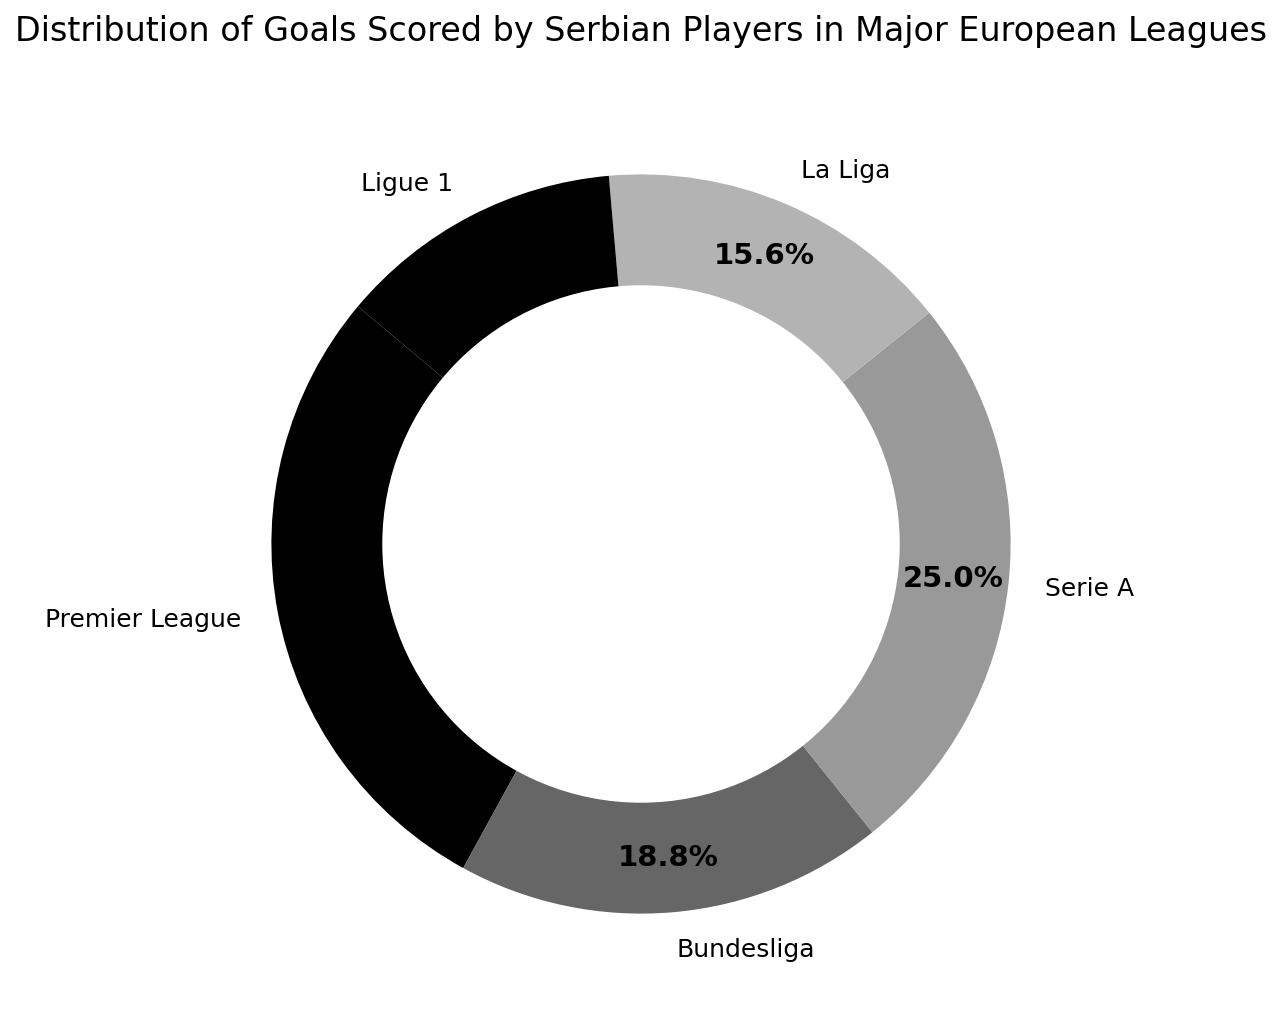Which league has the highest percentage of goals scored? The ring chart shows the distribution of goals scored by Serbian players in different leagues, represented in percentages. We look for the league with the largest segment in the chart.
Answer: Premier League What is the combined percentage of goals scored in the Bundesliga and La Liga? We find the segments for Bundesliga and La Liga and add their percentages. Bundesliga has 30 goals and La Liga has 25 goals, out of a total of 160 goals. Calculating: (30+25)/160 * 100 = 34.4%.
Answer: 34.4% How does the number of goals scored in Serie A compare to Ligue 1? We look at the segments representing Serie A and Ligue 1. Serie A has 40 goals and Ligue 1 has 20 goals. Serie A's segment is twice as large as Ligue 1's.
Answer: Serie A has twice as many goals as Ligue 1 Which league represents the smallest segment in the chart? The smallest segment in the ring chart represents the league with the least goals. By visual inspection, Ligue 1 has the smallest segment.
Answer: Ligue 1 What is the difference in the percentage of goals between the Premier League and La Liga? We find the percentages for Premier League and La Liga. Premier League’s percentage is ${45/160 * 100}$ and La Liga’s is ${25/160 * 100}$. The difference is ${(45/160 * 100) - (25/160 * 100)}$ = 12.5%.
Answer: 12.5% If goals in Ligue 1 doubled, what would be the new total number of goals and its percentage? Initially, Ligue 1 has 20 goals. Doubling it gives 40 goals. The new total number of goals will be 180 (160 original goals + 20 additional). The new percentage for Ligue 1 will be ${(40/180) * 100} = 22.2%$.
Answer: 22.2% What is the average number of goals scored per league? To find the average, sum the goals (45+30+40+25+20=160) and divide by the number of leagues (5). So, the average is ${160/5}$ = 32.
Answer: 32 Which two leagues have the most similar number of goals scored? By comparing the segments closely: Serie A (40 goals) and Premier League (45 goals) have the closest values, a difference of only 5 goals.
Answer: Premier League and Serie A What fraction of the total goals is scored in the Bundesliga? Bundesliga has 30 goals out of a total of 160 goals. The fraction is ${30/160}$, which simplifies to ${3/16}$.
Answer: 3/16 